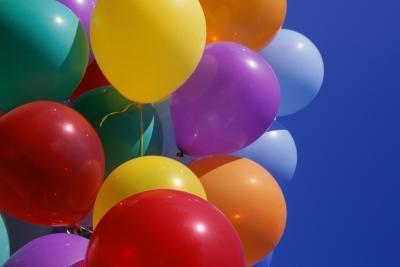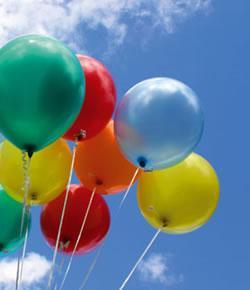The first image is the image on the left, the second image is the image on the right. Given the left and right images, does the statement "One person whose face cannot be seen is holding at least one balloon." hold true? Answer yes or no. No. 